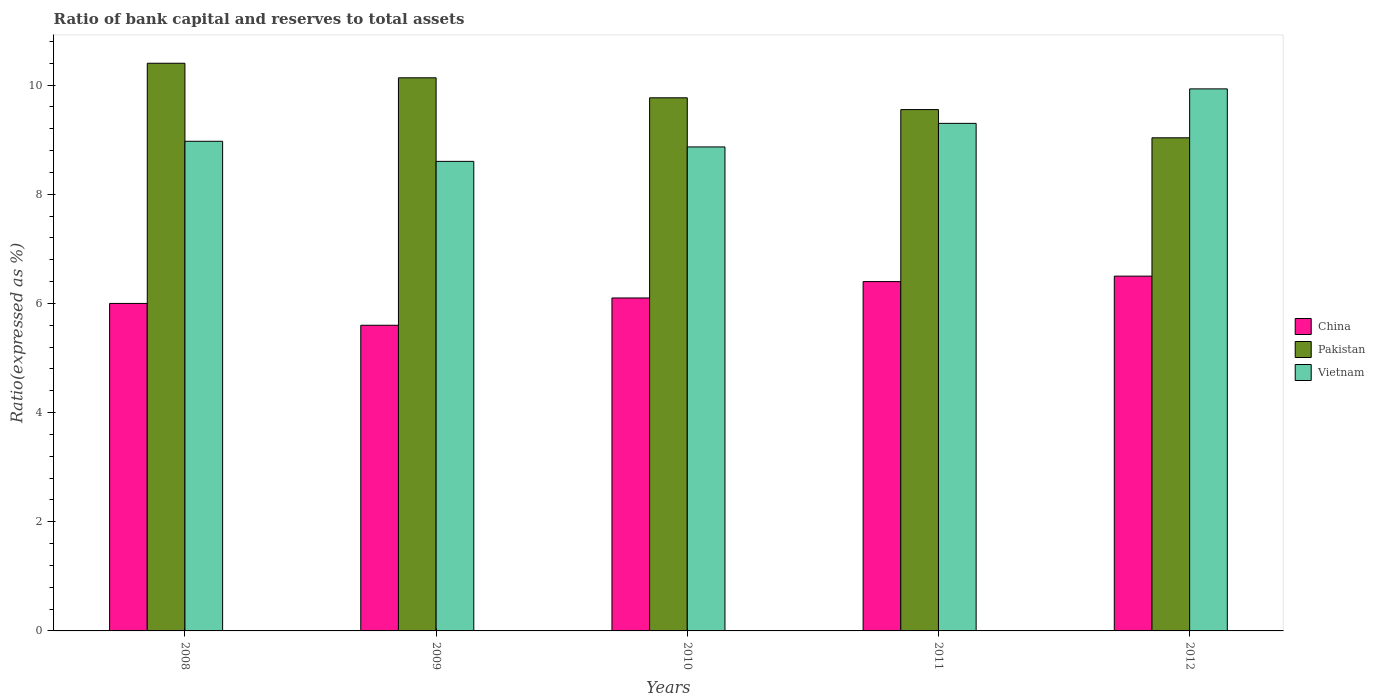How many different coloured bars are there?
Your response must be concise. 3. Are the number of bars per tick equal to the number of legend labels?
Your answer should be compact. Yes. How many bars are there on the 2nd tick from the left?
Ensure brevity in your answer.  3. What is the label of the 5th group of bars from the left?
Provide a short and direct response. 2012. In how many cases, is the number of bars for a given year not equal to the number of legend labels?
Give a very brief answer. 0. What is the ratio of bank capital and reserves to total assets in China in 2011?
Keep it short and to the point. 6.4. Across all years, what is the maximum ratio of bank capital and reserves to total assets in Pakistan?
Give a very brief answer. 10.4. Across all years, what is the minimum ratio of bank capital and reserves to total assets in China?
Offer a very short reply. 5.6. What is the total ratio of bank capital and reserves to total assets in Vietnam in the graph?
Offer a very short reply. 45.67. What is the difference between the ratio of bank capital and reserves to total assets in China in 2009 and that in 2010?
Make the answer very short. -0.5. What is the difference between the ratio of bank capital and reserves to total assets in Pakistan in 2008 and the ratio of bank capital and reserves to total assets in Vietnam in 2009?
Offer a very short reply. 1.8. What is the average ratio of bank capital and reserves to total assets in China per year?
Ensure brevity in your answer.  6.12. In the year 2010, what is the difference between the ratio of bank capital and reserves to total assets in Vietnam and ratio of bank capital and reserves to total assets in China?
Your response must be concise. 2.77. In how many years, is the ratio of bank capital and reserves to total assets in Pakistan greater than 4 %?
Make the answer very short. 5. What is the ratio of the ratio of bank capital and reserves to total assets in Pakistan in 2008 to that in 2009?
Give a very brief answer. 1.03. What is the difference between the highest and the second highest ratio of bank capital and reserves to total assets in Pakistan?
Make the answer very short. 0.27. What is the difference between the highest and the lowest ratio of bank capital and reserves to total assets in Vietnam?
Offer a terse response. 1.33. Is the sum of the ratio of bank capital and reserves to total assets in Pakistan in 2009 and 2011 greater than the maximum ratio of bank capital and reserves to total assets in China across all years?
Provide a short and direct response. Yes. What does the 2nd bar from the left in 2012 represents?
Offer a terse response. Pakistan. What does the 3rd bar from the right in 2012 represents?
Give a very brief answer. China. Is it the case that in every year, the sum of the ratio of bank capital and reserves to total assets in Vietnam and ratio of bank capital and reserves to total assets in China is greater than the ratio of bank capital and reserves to total assets in Pakistan?
Your answer should be very brief. Yes. How many bars are there?
Make the answer very short. 15. What is the difference between two consecutive major ticks on the Y-axis?
Provide a short and direct response. 2. Are the values on the major ticks of Y-axis written in scientific E-notation?
Your answer should be compact. No. Does the graph contain any zero values?
Your answer should be compact. No. How many legend labels are there?
Provide a short and direct response. 3. What is the title of the graph?
Offer a very short reply. Ratio of bank capital and reserves to total assets. What is the label or title of the X-axis?
Offer a very short reply. Years. What is the label or title of the Y-axis?
Make the answer very short. Ratio(expressed as %). What is the Ratio(expressed as %) of China in 2008?
Your answer should be compact. 6. What is the Ratio(expressed as %) in Pakistan in 2008?
Ensure brevity in your answer.  10.4. What is the Ratio(expressed as %) of Vietnam in 2008?
Keep it short and to the point. 8.97. What is the Ratio(expressed as %) of China in 2009?
Your answer should be compact. 5.6. What is the Ratio(expressed as %) of Pakistan in 2009?
Provide a succinct answer. 10.13. What is the Ratio(expressed as %) in Vietnam in 2009?
Offer a terse response. 8.6. What is the Ratio(expressed as %) in China in 2010?
Keep it short and to the point. 6.1. What is the Ratio(expressed as %) of Pakistan in 2010?
Make the answer very short. 9.77. What is the Ratio(expressed as %) of Vietnam in 2010?
Offer a very short reply. 8.87. What is the Ratio(expressed as %) of China in 2011?
Keep it short and to the point. 6.4. What is the Ratio(expressed as %) in Pakistan in 2011?
Keep it short and to the point. 9.55. What is the Ratio(expressed as %) in Vietnam in 2011?
Your answer should be compact. 9.3. What is the Ratio(expressed as %) in Pakistan in 2012?
Offer a very short reply. 9.03. What is the Ratio(expressed as %) of Vietnam in 2012?
Make the answer very short. 9.93. Across all years, what is the maximum Ratio(expressed as %) in Vietnam?
Your response must be concise. 9.93. Across all years, what is the minimum Ratio(expressed as %) of China?
Your answer should be very brief. 5.6. Across all years, what is the minimum Ratio(expressed as %) of Pakistan?
Your response must be concise. 9.03. Across all years, what is the minimum Ratio(expressed as %) of Vietnam?
Your response must be concise. 8.6. What is the total Ratio(expressed as %) in China in the graph?
Make the answer very short. 30.6. What is the total Ratio(expressed as %) in Pakistan in the graph?
Keep it short and to the point. 48.89. What is the total Ratio(expressed as %) of Vietnam in the graph?
Your response must be concise. 45.67. What is the difference between the Ratio(expressed as %) in China in 2008 and that in 2009?
Your answer should be very brief. 0.4. What is the difference between the Ratio(expressed as %) in Pakistan in 2008 and that in 2009?
Keep it short and to the point. 0.27. What is the difference between the Ratio(expressed as %) of Vietnam in 2008 and that in 2009?
Offer a terse response. 0.37. What is the difference between the Ratio(expressed as %) in China in 2008 and that in 2010?
Ensure brevity in your answer.  -0.1. What is the difference between the Ratio(expressed as %) of Pakistan in 2008 and that in 2010?
Offer a terse response. 0.63. What is the difference between the Ratio(expressed as %) in Vietnam in 2008 and that in 2010?
Give a very brief answer. 0.1. What is the difference between the Ratio(expressed as %) in China in 2008 and that in 2011?
Give a very brief answer. -0.4. What is the difference between the Ratio(expressed as %) in Pakistan in 2008 and that in 2011?
Offer a terse response. 0.85. What is the difference between the Ratio(expressed as %) of Vietnam in 2008 and that in 2011?
Offer a very short reply. -0.33. What is the difference between the Ratio(expressed as %) in Pakistan in 2008 and that in 2012?
Your answer should be very brief. 1.37. What is the difference between the Ratio(expressed as %) in Vietnam in 2008 and that in 2012?
Offer a terse response. -0.96. What is the difference between the Ratio(expressed as %) in Pakistan in 2009 and that in 2010?
Offer a very short reply. 0.37. What is the difference between the Ratio(expressed as %) of Vietnam in 2009 and that in 2010?
Your answer should be compact. -0.26. What is the difference between the Ratio(expressed as %) in China in 2009 and that in 2011?
Keep it short and to the point. -0.8. What is the difference between the Ratio(expressed as %) of Pakistan in 2009 and that in 2011?
Your answer should be compact. 0.58. What is the difference between the Ratio(expressed as %) in Vietnam in 2009 and that in 2011?
Give a very brief answer. -0.7. What is the difference between the Ratio(expressed as %) in China in 2009 and that in 2012?
Your answer should be compact. -0.9. What is the difference between the Ratio(expressed as %) in Pakistan in 2009 and that in 2012?
Ensure brevity in your answer.  1.1. What is the difference between the Ratio(expressed as %) in Vietnam in 2009 and that in 2012?
Ensure brevity in your answer.  -1.33. What is the difference between the Ratio(expressed as %) of Pakistan in 2010 and that in 2011?
Make the answer very short. 0.22. What is the difference between the Ratio(expressed as %) in Vietnam in 2010 and that in 2011?
Provide a succinct answer. -0.43. What is the difference between the Ratio(expressed as %) in Pakistan in 2010 and that in 2012?
Your answer should be compact. 0.73. What is the difference between the Ratio(expressed as %) in Vietnam in 2010 and that in 2012?
Offer a very short reply. -1.06. What is the difference between the Ratio(expressed as %) of Pakistan in 2011 and that in 2012?
Offer a terse response. 0.52. What is the difference between the Ratio(expressed as %) in Vietnam in 2011 and that in 2012?
Offer a very short reply. -0.63. What is the difference between the Ratio(expressed as %) of China in 2008 and the Ratio(expressed as %) of Pakistan in 2009?
Your response must be concise. -4.13. What is the difference between the Ratio(expressed as %) of China in 2008 and the Ratio(expressed as %) of Vietnam in 2009?
Offer a very short reply. -2.6. What is the difference between the Ratio(expressed as %) in Pakistan in 2008 and the Ratio(expressed as %) in Vietnam in 2009?
Offer a terse response. 1.8. What is the difference between the Ratio(expressed as %) of China in 2008 and the Ratio(expressed as %) of Pakistan in 2010?
Your answer should be very brief. -3.77. What is the difference between the Ratio(expressed as %) in China in 2008 and the Ratio(expressed as %) in Vietnam in 2010?
Give a very brief answer. -2.87. What is the difference between the Ratio(expressed as %) of Pakistan in 2008 and the Ratio(expressed as %) of Vietnam in 2010?
Offer a terse response. 1.53. What is the difference between the Ratio(expressed as %) in China in 2008 and the Ratio(expressed as %) in Pakistan in 2011?
Ensure brevity in your answer.  -3.55. What is the difference between the Ratio(expressed as %) of China in 2008 and the Ratio(expressed as %) of Vietnam in 2011?
Your response must be concise. -3.3. What is the difference between the Ratio(expressed as %) of Pakistan in 2008 and the Ratio(expressed as %) of Vietnam in 2011?
Provide a short and direct response. 1.1. What is the difference between the Ratio(expressed as %) of China in 2008 and the Ratio(expressed as %) of Pakistan in 2012?
Make the answer very short. -3.03. What is the difference between the Ratio(expressed as %) in China in 2008 and the Ratio(expressed as %) in Vietnam in 2012?
Provide a short and direct response. -3.93. What is the difference between the Ratio(expressed as %) in Pakistan in 2008 and the Ratio(expressed as %) in Vietnam in 2012?
Your answer should be compact. 0.47. What is the difference between the Ratio(expressed as %) in China in 2009 and the Ratio(expressed as %) in Pakistan in 2010?
Make the answer very short. -4.17. What is the difference between the Ratio(expressed as %) of China in 2009 and the Ratio(expressed as %) of Vietnam in 2010?
Provide a succinct answer. -3.27. What is the difference between the Ratio(expressed as %) of Pakistan in 2009 and the Ratio(expressed as %) of Vietnam in 2010?
Give a very brief answer. 1.27. What is the difference between the Ratio(expressed as %) in China in 2009 and the Ratio(expressed as %) in Pakistan in 2011?
Make the answer very short. -3.95. What is the difference between the Ratio(expressed as %) of China in 2009 and the Ratio(expressed as %) of Vietnam in 2011?
Make the answer very short. -3.7. What is the difference between the Ratio(expressed as %) of Pakistan in 2009 and the Ratio(expressed as %) of Vietnam in 2011?
Provide a succinct answer. 0.83. What is the difference between the Ratio(expressed as %) of China in 2009 and the Ratio(expressed as %) of Pakistan in 2012?
Make the answer very short. -3.43. What is the difference between the Ratio(expressed as %) in China in 2009 and the Ratio(expressed as %) in Vietnam in 2012?
Keep it short and to the point. -4.33. What is the difference between the Ratio(expressed as %) of Pakistan in 2009 and the Ratio(expressed as %) of Vietnam in 2012?
Your answer should be very brief. 0.2. What is the difference between the Ratio(expressed as %) of China in 2010 and the Ratio(expressed as %) of Pakistan in 2011?
Keep it short and to the point. -3.45. What is the difference between the Ratio(expressed as %) of China in 2010 and the Ratio(expressed as %) of Vietnam in 2011?
Provide a short and direct response. -3.2. What is the difference between the Ratio(expressed as %) of Pakistan in 2010 and the Ratio(expressed as %) of Vietnam in 2011?
Your response must be concise. 0.47. What is the difference between the Ratio(expressed as %) of China in 2010 and the Ratio(expressed as %) of Pakistan in 2012?
Make the answer very short. -2.93. What is the difference between the Ratio(expressed as %) in China in 2010 and the Ratio(expressed as %) in Vietnam in 2012?
Your answer should be compact. -3.83. What is the difference between the Ratio(expressed as %) in Pakistan in 2010 and the Ratio(expressed as %) in Vietnam in 2012?
Provide a short and direct response. -0.16. What is the difference between the Ratio(expressed as %) of China in 2011 and the Ratio(expressed as %) of Pakistan in 2012?
Provide a short and direct response. -2.63. What is the difference between the Ratio(expressed as %) of China in 2011 and the Ratio(expressed as %) of Vietnam in 2012?
Offer a terse response. -3.53. What is the difference between the Ratio(expressed as %) in Pakistan in 2011 and the Ratio(expressed as %) in Vietnam in 2012?
Make the answer very short. -0.38. What is the average Ratio(expressed as %) in China per year?
Make the answer very short. 6.12. What is the average Ratio(expressed as %) in Pakistan per year?
Make the answer very short. 9.78. What is the average Ratio(expressed as %) in Vietnam per year?
Your answer should be very brief. 9.13. In the year 2008, what is the difference between the Ratio(expressed as %) of China and Ratio(expressed as %) of Pakistan?
Give a very brief answer. -4.4. In the year 2008, what is the difference between the Ratio(expressed as %) in China and Ratio(expressed as %) in Vietnam?
Offer a terse response. -2.97. In the year 2008, what is the difference between the Ratio(expressed as %) of Pakistan and Ratio(expressed as %) of Vietnam?
Give a very brief answer. 1.43. In the year 2009, what is the difference between the Ratio(expressed as %) in China and Ratio(expressed as %) in Pakistan?
Offer a very short reply. -4.53. In the year 2009, what is the difference between the Ratio(expressed as %) of China and Ratio(expressed as %) of Vietnam?
Keep it short and to the point. -3. In the year 2009, what is the difference between the Ratio(expressed as %) of Pakistan and Ratio(expressed as %) of Vietnam?
Give a very brief answer. 1.53. In the year 2010, what is the difference between the Ratio(expressed as %) of China and Ratio(expressed as %) of Pakistan?
Your answer should be compact. -3.67. In the year 2010, what is the difference between the Ratio(expressed as %) in China and Ratio(expressed as %) in Vietnam?
Your response must be concise. -2.77. In the year 2010, what is the difference between the Ratio(expressed as %) in Pakistan and Ratio(expressed as %) in Vietnam?
Keep it short and to the point. 0.9. In the year 2011, what is the difference between the Ratio(expressed as %) of China and Ratio(expressed as %) of Pakistan?
Provide a short and direct response. -3.15. In the year 2011, what is the difference between the Ratio(expressed as %) in China and Ratio(expressed as %) in Vietnam?
Give a very brief answer. -2.9. In the year 2011, what is the difference between the Ratio(expressed as %) in Pakistan and Ratio(expressed as %) in Vietnam?
Ensure brevity in your answer.  0.25. In the year 2012, what is the difference between the Ratio(expressed as %) of China and Ratio(expressed as %) of Pakistan?
Offer a very short reply. -2.53. In the year 2012, what is the difference between the Ratio(expressed as %) in China and Ratio(expressed as %) in Vietnam?
Your response must be concise. -3.43. In the year 2012, what is the difference between the Ratio(expressed as %) in Pakistan and Ratio(expressed as %) in Vietnam?
Ensure brevity in your answer.  -0.9. What is the ratio of the Ratio(expressed as %) in China in 2008 to that in 2009?
Keep it short and to the point. 1.07. What is the ratio of the Ratio(expressed as %) in Pakistan in 2008 to that in 2009?
Your response must be concise. 1.03. What is the ratio of the Ratio(expressed as %) of Vietnam in 2008 to that in 2009?
Your response must be concise. 1.04. What is the ratio of the Ratio(expressed as %) of China in 2008 to that in 2010?
Your answer should be compact. 0.98. What is the ratio of the Ratio(expressed as %) of Pakistan in 2008 to that in 2010?
Make the answer very short. 1.06. What is the ratio of the Ratio(expressed as %) in Vietnam in 2008 to that in 2010?
Give a very brief answer. 1.01. What is the ratio of the Ratio(expressed as %) of China in 2008 to that in 2011?
Your response must be concise. 0.94. What is the ratio of the Ratio(expressed as %) in Pakistan in 2008 to that in 2011?
Your answer should be very brief. 1.09. What is the ratio of the Ratio(expressed as %) of Vietnam in 2008 to that in 2011?
Your response must be concise. 0.96. What is the ratio of the Ratio(expressed as %) of China in 2008 to that in 2012?
Your answer should be very brief. 0.92. What is the ratio of the Ratio(expressed as %) of Pakistan in 2008 to that in 2012?
Your response must be concise. 1.15. What is the ratio of the Ratio(expressed as %) of Vietnam in 2008 to that in 2012?
Your response must be concise. 0.9. What is the ratio of the Ratio(expressed as %) in China in 2009 to that in 2010?
Your answer should be compact. 0.92. What is the ratio of the Ratio(expressed as %) in Pakistan in 2009 to that in 2010?
Ensure brevity in your answer.  1.04. What is the ratio of the Ratio(expressed as %) of Vietnam in 2009 to that in 2010?
Offer a very short reply. 0.97. What is the ratio of the Ratio(expressed as %) of Pakistan in 2009 to that in 2011?
Provide a succinct answer. 1.06. What is the ratio of the Ratio(expressed as %) of Vietnam in 2009 to that in 2011?
Ensure brevity in your answer.  0.93. What is the ratio of the Ratio(expressed as %) of China in 2009 to that in 2012?
Your response must be concise. 0.86. What is the ratio of the Ratio(expressed as %) of Pakistan in 2009 to that in 2012?
Provide a succinct answer. 1.12. What is the ratio of the Ratio(expressed as %) of Vietnam in 2009 to that in 2012?
Offer a terse response. 0.87. What is the ratio of the Ratio(expressed as %) of China in 2010 to that in 2011?
Offer a very short reply. 0.95. What is the ratio of the Ratio(expressed as %) of Pakistan in 2010 to that in 2011?
Your answer should be very brief. 1.02. What is the ratio of the Ratio(expressed as %) of Vietnam in 2010 to that in 2011?
Keep it short and to the point. 0.95. What is the ratio of the Ratio(expressed as %) of China in 2010 to that in 2012?
Make the answer very short. 0.94. What is the ratio of the Ratio(expressed as %) of Pakistan in 2010 to that in 2012?
Provide a short and direct response. 1.08. What is the ratio of the Ratio(expressed as %) of Vietnam in 2010 to that in 2012?
Offer a very short reply. 0.89. What is the ratio of the Ratio(expressed as %) in China in 2011 to that in 2012?
Your answer should be compact. 0.98. What is the ratio of the Ratio(expressed as %) in Pakistan in 2011 to that in 2012?
Ensure brevity in your answer.  1.06. What is the ratio of the Ratio(expressed as %) in Vietnam in 2011 to that in 2012?
Offer a terse response. 0.94. What is the difference between the highest and the second highest Ratio(expressed as %) in China?
Your response must be concise. 0.1. What is the difference between the highest and the second highest Ratio(expressed as %) of Pakistan?
Your response must be concise. 0.27. What is the difference between the highest and the second highest Ratio(expressed as %) of Vietnam?
Your answer should be very brief. 0.63. What is the difference between the highest and the lowest Ratio(expressed as %) in China?
Provide a succinct answer. 0.9. What is the difference between the highest and the lowest Ratio(expressed as %) of Pakistan?
Provide a succinct answer. 1.37. What is the difference between the highest and the lowest Ratio(expressed as %) in Vietnam?
Your answer should be compact. 1.33. 